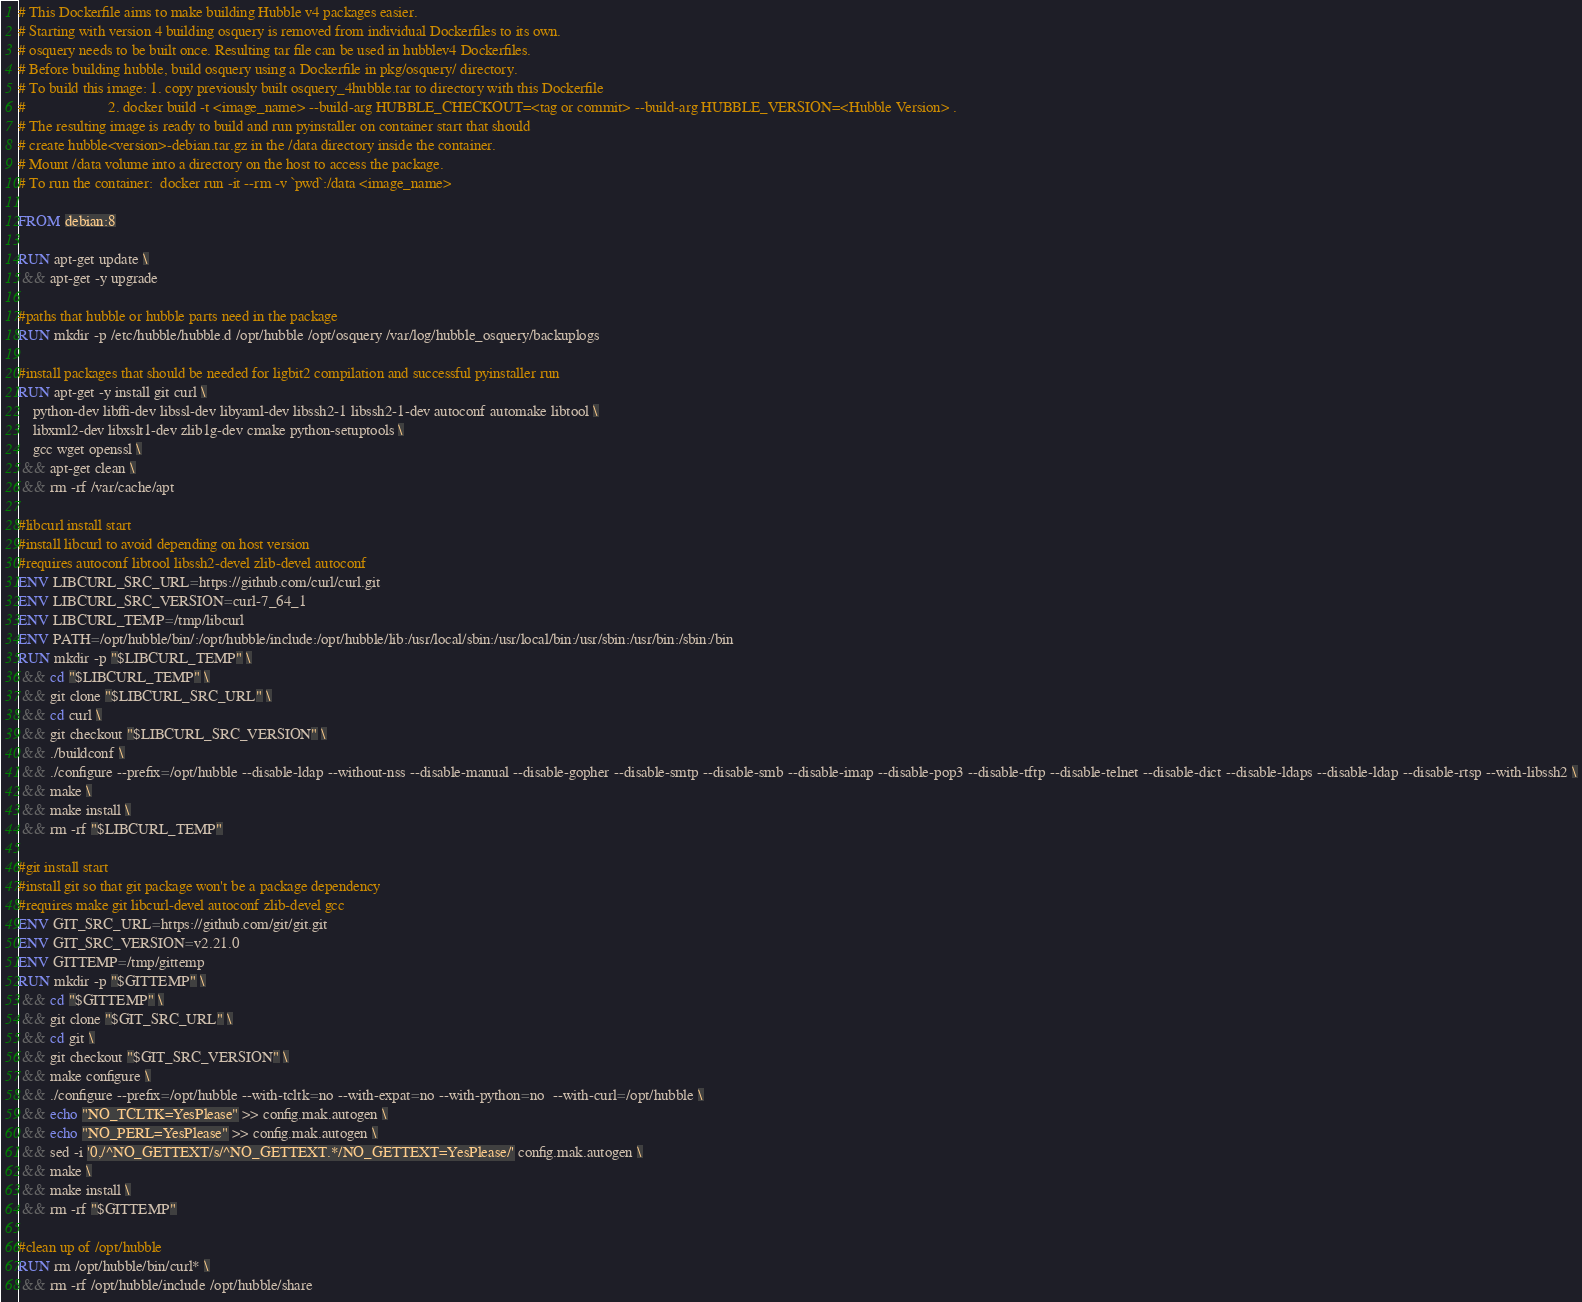Convert code to text. <code><loc_0><loc_0><loc_500><loc_500><_Dockerfile_># This Dockerfile aims to make building Hubble v4 packages easier.
# Starting with version 4 building osquery is removed from individual Dockerfiles to its own.
# osquery needs to be built once. Resulting tar file can be used in hubblev4 Dockerfiles.
# Before building hubble, build osquery using a Dockerfile in pkg/osquery/ directory.
# To build this image: 1. copy previously built osquery_4hubble.tar to directory with this Dockerfile
#                      2. docker build -t <image_name> --build-arg HUBBLE_CHECKOUT=<tag or commit> --build-arg HUBBLE_VERSION=<Hubble Version> .
# The resulting image is ready to build and run pyinstaller on container start that should 
# create hubble<version>-debian.tar.gz in the /data directory inside the container.
# Mount /data volume into a directory on the host to access the package.
# To run the container:  docker run -it --rm -v `pwd`:/data <image_name>

FROM debian:8

RUN apt-get update \
 && apt-get -y upgrade

#paths that hubble or hubble parts need in the package
RUN mkdir -p /etc/hubble/hubble.d /opt/hubble /opt/osquery /var/log/hubble_osquery/backuplogs

#install packages that should be needed for ligbit2 compilation and successful pyinstaller run
RUN apt-get -y install git curl \
    python-dev libffi-dev libssl-dev libyaml-dev libssh2-1 libssh2-1-dev autoconf automake libtool \
    libxml2-dev libxslt1-dev zlib1g-dev cmake python-setuptools \
    gcc wget openssl \
 && apt-get clean \
 && rm -rf /var/cache/apt

#libcurl install start
#install libcurl to avoid depending on host version
#requires autoconf libtool libssh2-devel zlib-devel autoconf
ENV LIBCURL_SRC_URL=https://github.com/curl/curl.git
ENV LIBCURL_SRC_VERSION=curl-7_64_1
ENV LIBCURL_TEMP=/tmp/libcurl
ENV PATH=/opt/hubble/bin/:/opt/hubble/include:/opt/hubble/lib:/usr/local/sbin:/usr/local/bin:/usr/sbin:/usr/bin:/sbin:/bin
RUN mkdir -p "$LIBCURL_TEMP" \
 && cd "$LIBCURL_TEMP" \
 && git clone "$LIBCURL_SRC_URL" \
 && cd curl \
 && git checkout "$LIBCURL_SRC_VERSION" \
 && ./buildconf \
 && ./configure --prefix=/opt/hubble --disable-ldap --without-nss --disable-manual --disable-gopher --disable-smtp --disable-smb --disable-imap --disable-pop3 --disable-tftp --disable-telnet --disable-dict --disable-ldaps --disable-ldap --disable-rtsp --with-libssh2 \
 && make \
 && make install \
 && rm -rf "$LIBCURL_TEMP"

#git install start
#install git so that git package won't be a package dependency
#requires make git libcurl-devel autoconf zlib-devel gcc
ENV GIT_SRC_URL=https://github.com/git/git.git
ENV GIT_SRC_VERSION=v2.21.0
ENV GITTEMP=/tmp/gittemp
RUN mkdir -p "$GITTEMP" \
 && cd "$GITTEMP" \
 && git clone "$GIT_SRC_URL" \
 && cd git \
 && git checkout "$GIT_SRC_VERSION" \
 && make configure \
 && ./configure --prefix=/opt/hubble --with-tcltk=no --with-expat=no --with-python=no  --with-curl=/opt/hubble \
 && echo "NO_TCLTK=YesPlease" >> config.mak.autogen \
 && echo "NO_PERL=YesPlease" >> config.mak.autogen \
 && sed -i '0,/^NO_GETTEXT/s/^NO_GETTEXT.*/NO_GETTEXT=YesPlease/' config.mak.autogen \
 && make \
 && make install \
 && rm -rf "$GITTEMP"

#clean up of /opt/hubble
RUN rm /opt/hubble/bin/curl* \
 && rm -rf /opt/hubble/include /opt/hubble/share
</code> 